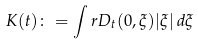Convert formula to latex. <formula><loc_0><loc_0><loc_500><loc_500>K ( t ) \colon = \int r D _ { t } ( 0 , \xi ) | \xi | \, d \xi</formula> 